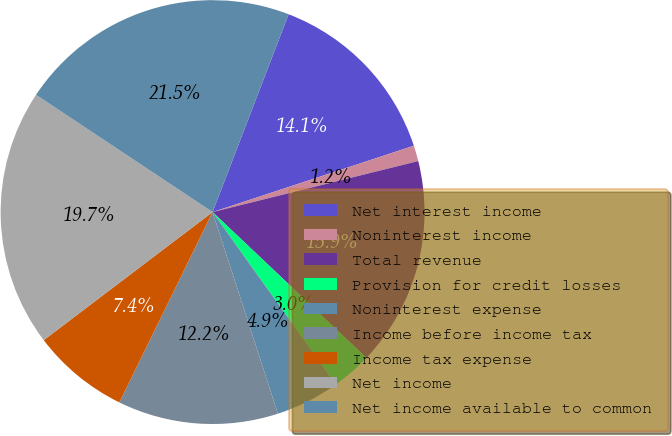<chart> <loc_0><loc_0><loc_500><loc_500><pie_chart><fcel>Net interest income<fcel>Noninterest income<fcel>Total revenue<fcel>Provision for credit losses<fcel>Noninterest expense<fcel>Income before income tax<fcel>Income tax expense<fcel>Net income<fcel>Net income available to common<nl><fcel>14.09%<fcel>1.2%<fcel>15.94%<fcel>3.05%<fcel>4.89%<fcel>12.24%<fcel>7.42%<fcel>19.66%<fcel>21.51%<nl></chart> 